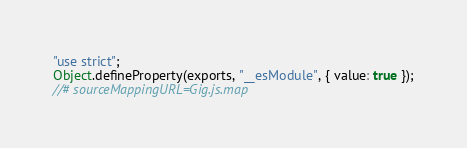Convert code to text. <code><loc_0><loc_0><loc_500><loc_500><_JavaScript_>"use strict";
Object.defineProperty(exports, "__esModule", { value: true });
//# sourceMappingURL=Gig.js.map</code> 